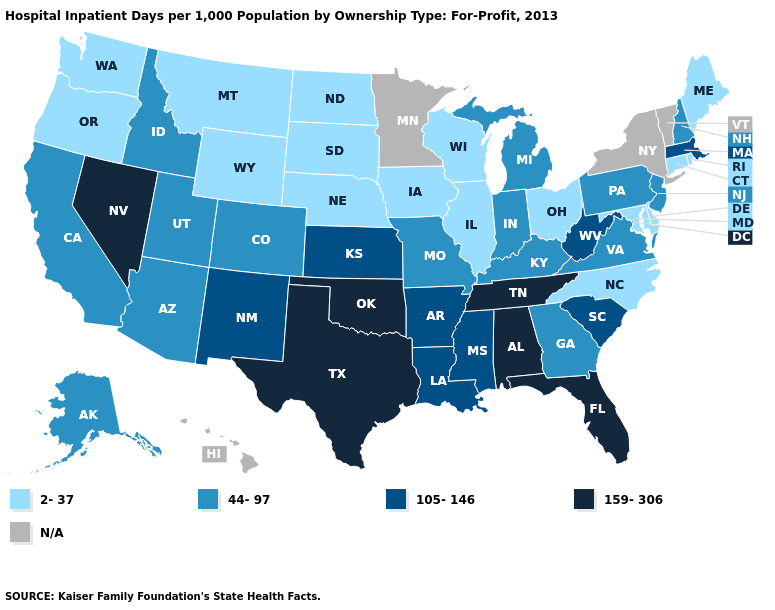Among the states that border Arizona , which have the lowest value?
Be succinct. California, Colorado, Utah. Name the states that have a value in the range 105-146?
Concise answer only. Arkansas, Kansas, Louisiana, Massachusetts, Mississippi, New Mexico, South Carolina, West Virginia. Name the states that have a value in the range 159-306?
Be succinct. Alabama, Florida, Nevada, Oklahoma, Tennessee, Texas. Among the states that border New Jersey , does Delaware have the highest value?
Short answer required. No. Which states hav the highest value in the Northeast?
Quick response, please. Massachusetts. What is the highest value in states that border Louisiana?
Concise answer only. 159-306. Name the states that have a value in the range 159-306?
Write a very short answer. Alabama, Florida, Nevada, Oklahoma, Tennessee, Texas. What is the value of Mississippi?
Answer briefly. 105-146. What is the value of Connecticut?
Concise answer only. 2-37. What is the value of North Dakota?
Give a very brief answer. 2-37. What is the value of Oklahoma?
Keep it brief. 159-306. Does the first symbol in the legend represent the smallest category?
Keep it brief. Yes. What is the value of Wyoming?
Be succinct. 2-37. 